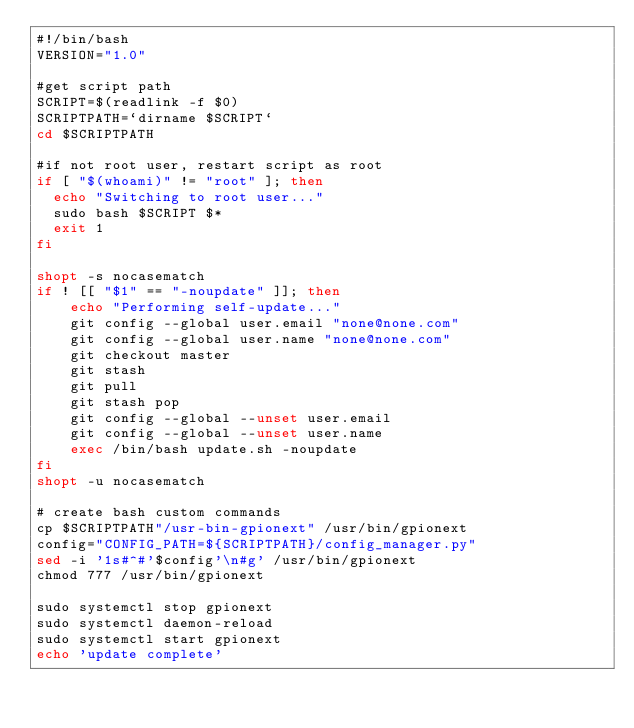Convert code to text. <code><loc_0><loc_0><loc_500><loc_500><_Bash_>#!/bin/bash
VERSION="1.0"

#get script path
SCRIPT=$(readlink -f $0)
SCRIPTPATH=`dirname $SCRIPT`
cd $SCRIPTPATH

#if not root user, restart script as root
if [ "$(whoami)" != "root" ]; then
	echo "Switching to root user..."
	sudo bash $SCRIPT $*
	exit 1
fi

shopt -s nocasematch
if ! [[ "$1" == "-noupdate" ]]; then
    echo "Performing self-update..."
    git config --global user.email "none@none.com"
    git config --global user.name "none@none.com"
    git checkout master
    git stash
    git pull
    git stash pop
    git config --global --unset user.email
    git config --global --unset user.name
    exec /bin/bash update.sh -noupdate
fi
shopt -u nocasematch

# create bash custom commands
cp $SCRIPTPATH"/usr-bin-gpionext" /usr/bin/gpionext
config="CONFIG_PATH=${SCRIPTPATH}/config_manager.py"
sed -i '1s#^#'$config'\n#g' /usr/bin/gpionext
chmod 777 /usr/bin/gpionext

sudo systemctl stop gpionext
sudo systemctl daemon-reload
sudo systemctl start gpionext
echo 'update complete'
</code> 